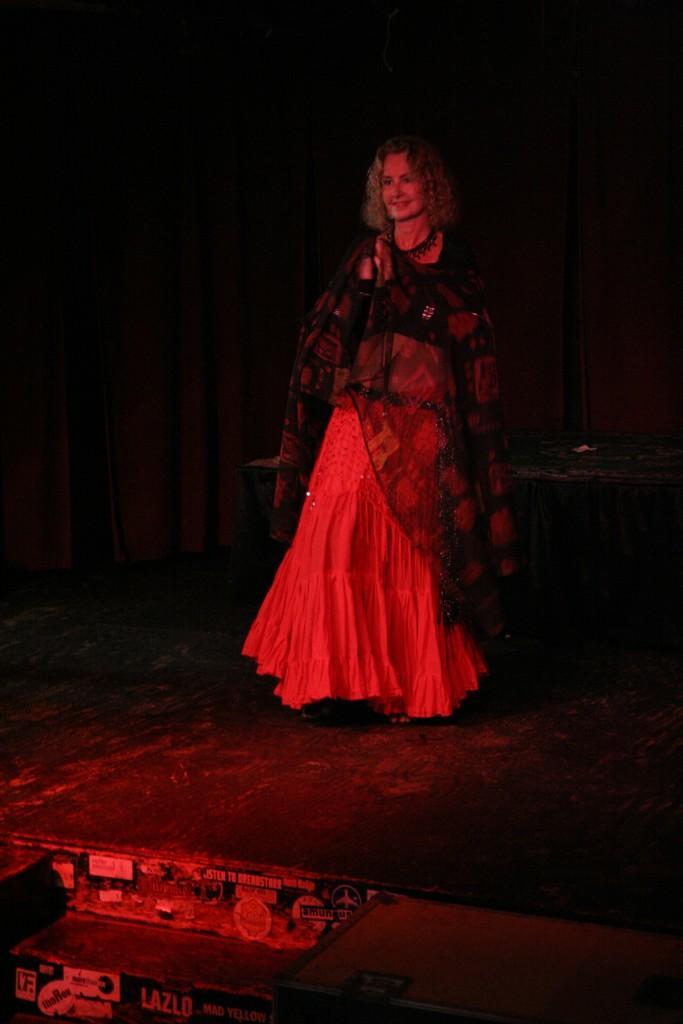Please provide a concise description of this image. In this picture in the center there is a woman standing and smiling. In the front there is an object which is black in colour and there are boards with some text written on it. 